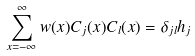<formula> <loc_0><loc_0><loc_500><loc_500>\sum _ { x = - \infty } ^ { \infty } w ( x ) C _ { j } ( x ) C _ { l } ( x ) = \delta _ { j l } h _ { j }</formula> 